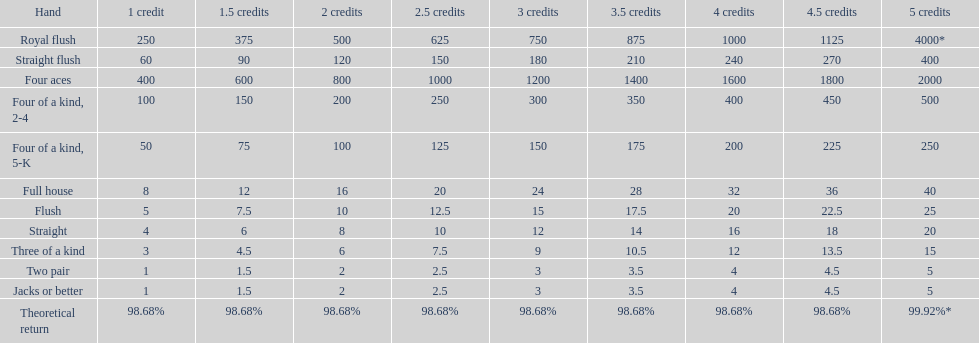The number of flush wins at one credit to equal one flush win at 5 credits. 5. 